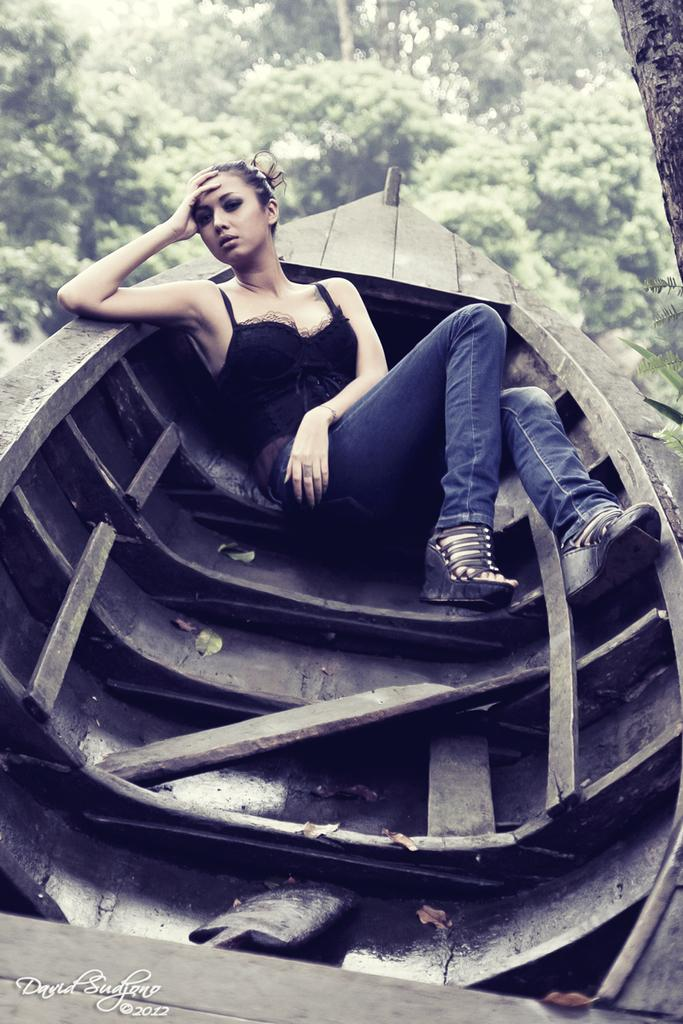What is the person in the image doing? There is a person sitting in a boat in the image. What is the person wearing? The person is wearing a black shirt and blue pants. What can be seen in the background of the image? There are trees visible in the background. What is the color of the trees in the image? The trees are green in color. Can you hear the dinosaurs laughing in the image? There are no dinosaurs or sounds present in the image, so it is not possible to hear any laughter. 